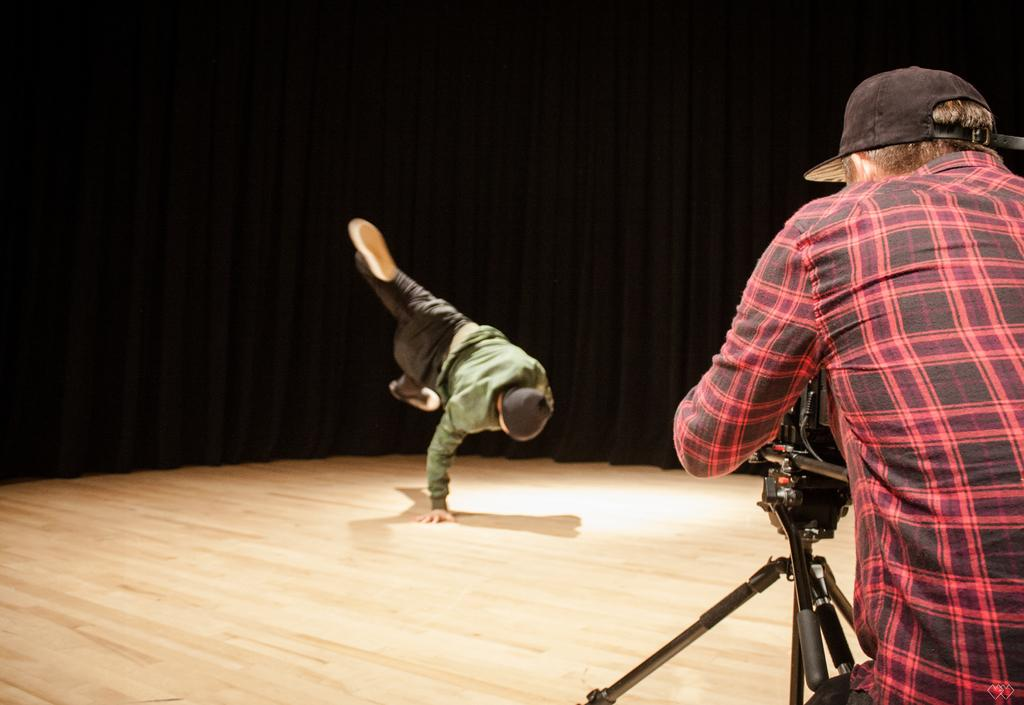How many people are in the image? There are two people in the image. Can you describe one of the people in the image? One of the people is a man. What is the man doing in the image? The man is standing on the floor. What object can be seen in the image that is typically used for photography? There is a tripod stand in the image. What is the color of the background in the image? The background of the image is dark. What type of song is being sung by the man in the image? There is no indication in the image that the man is singing a song, so it cannot be determined from the picture. 